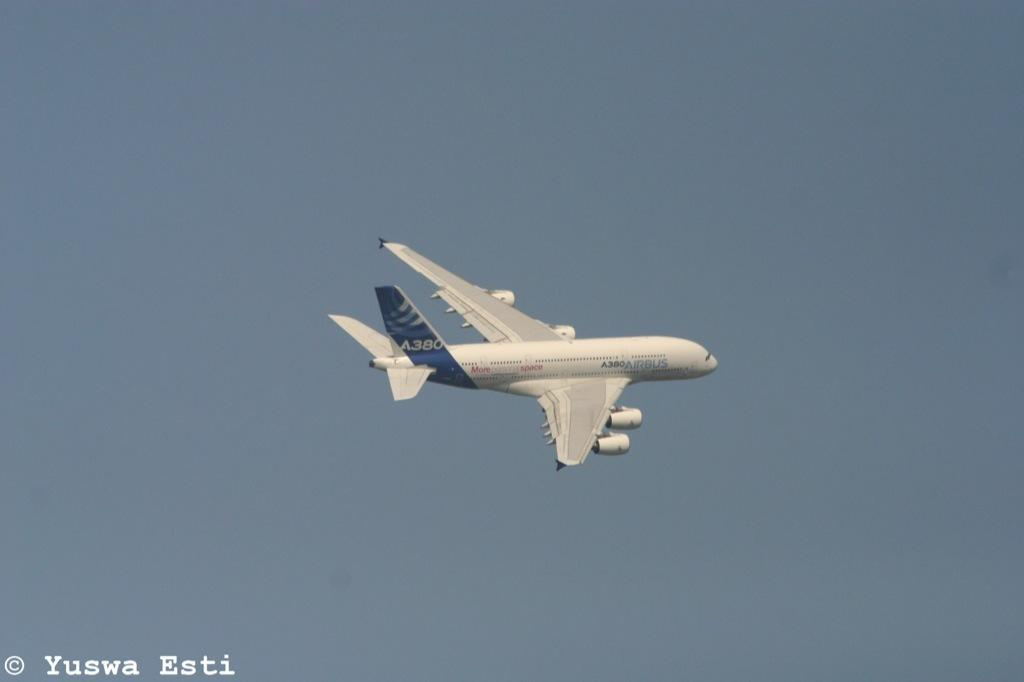What is the main subject of the image? The main subject of the image is an aircraft. Can you describe the position of the aircraft in the image? The aircraft is in the air in the image. What colors are used to paint the aircraft? The aircraft is blue and white in color. What can be seen in the background of the image? The sky is visible in the background of the image. What is the color of the sky in the image? The sky is blue in color. What type of nation is depicted on the aircraft's tail in the image? There is no nation depicted on the aircraft's tail in the image. Can you tell me how many sofas are visible in the image? There are no sofas present in the image. 